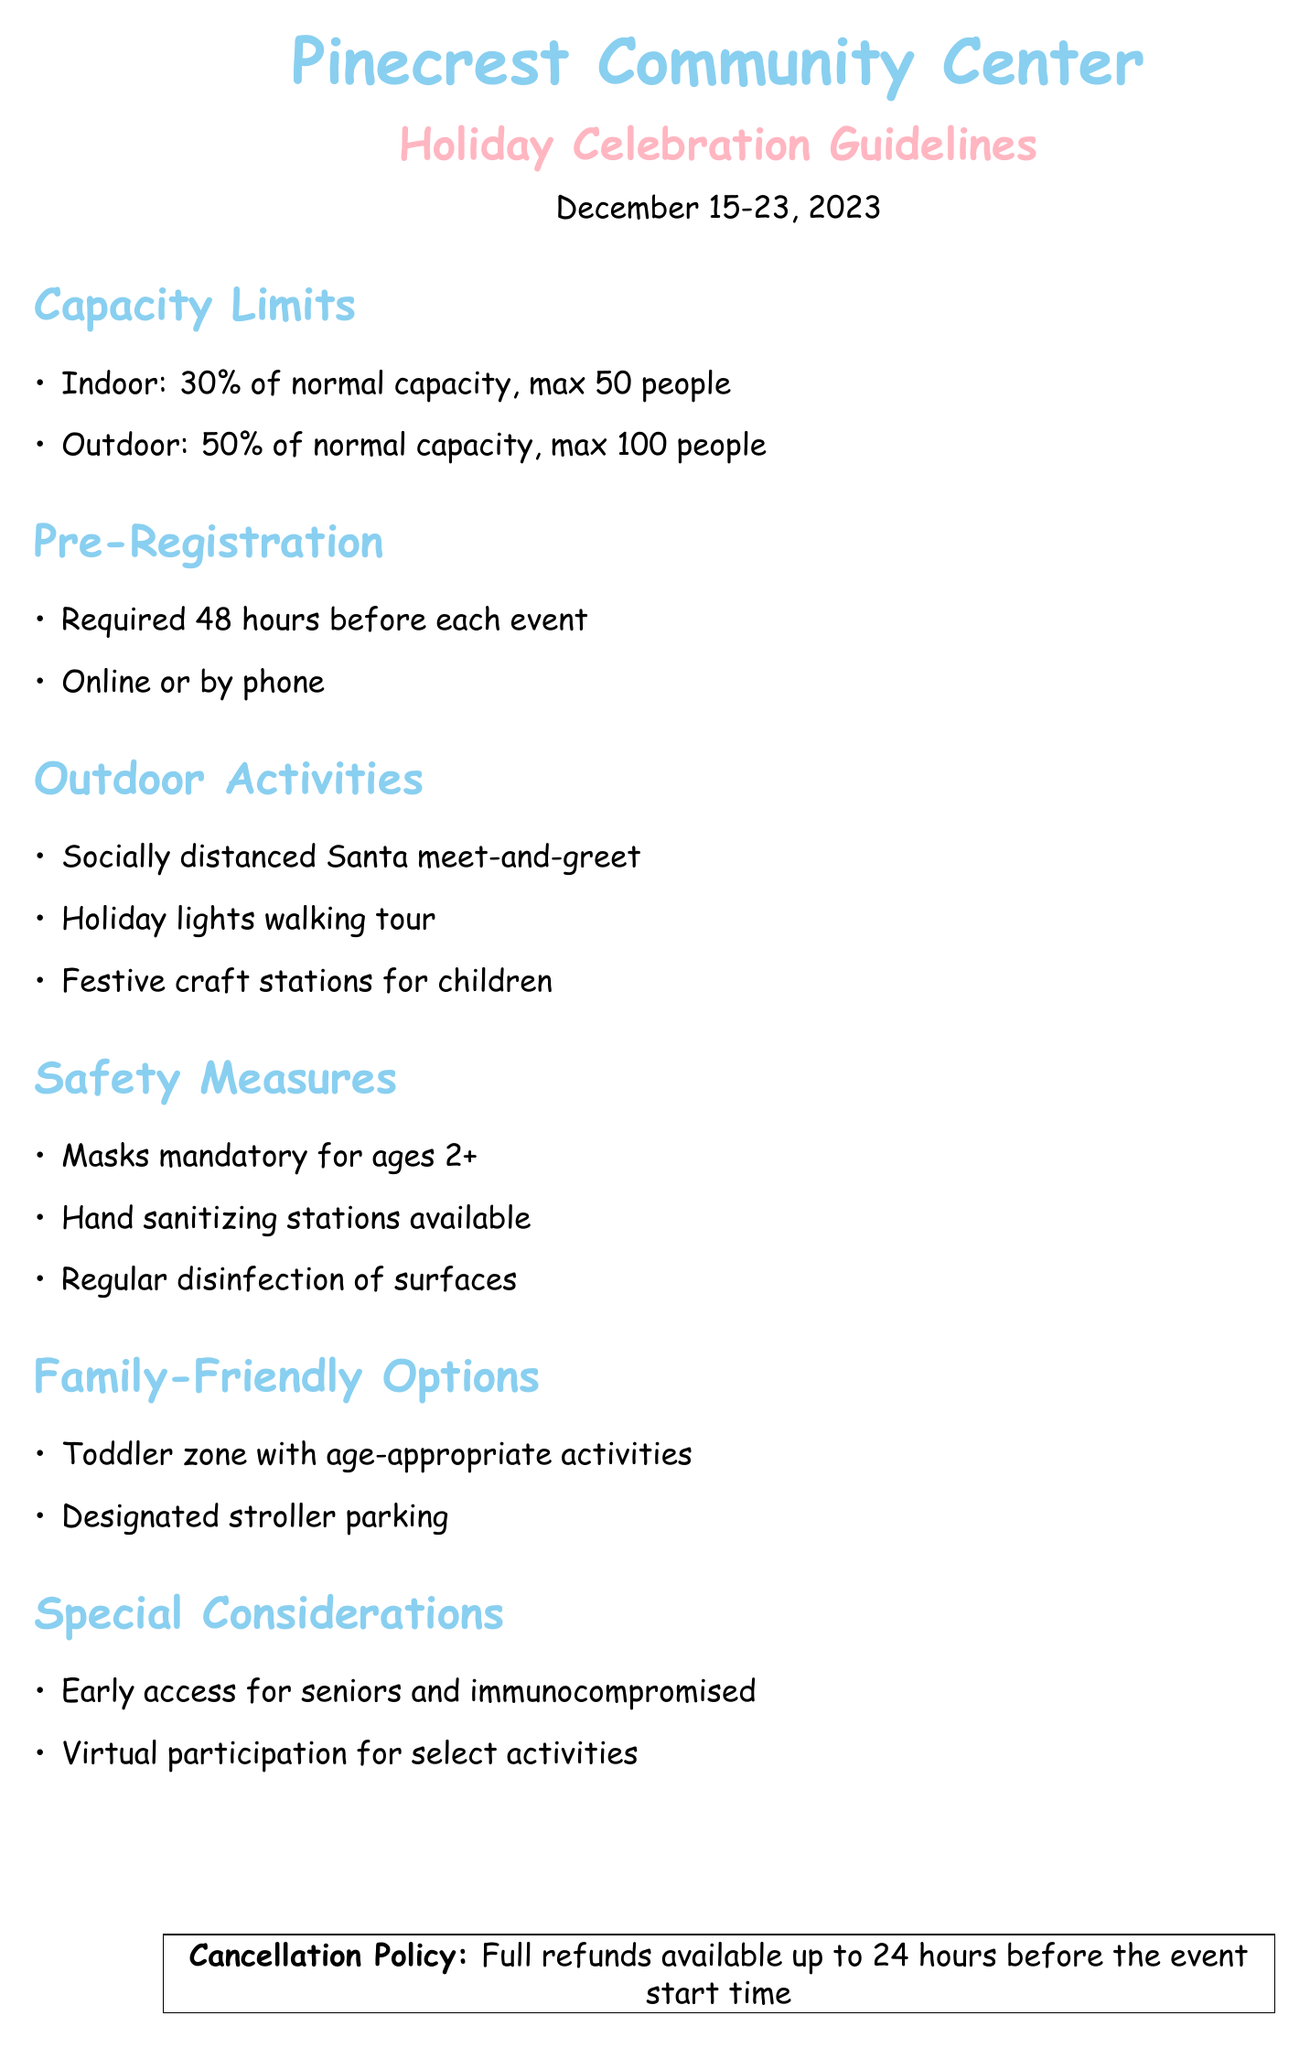What is the maximum indoor capacity for the holiday events? The maximum indoor capacity is specified in the guidelines as 50 people.
Answer: 50 people What are the pre-registration requirements? The guidelines state that pre-registration is required 48 hours before each event, either online or by phone.
Answer: 48 hours, online or by phone What is the maximum outdoor capacity for the holiday events? The guidelines specify that the maximum outdoor capacity is 100 people.
Answer: 100 people What types of activities are planned for outdoor events? The document outlines outdoor activities including a Santa meet-and-greet, walking tour, and craft stations.
Answer: Santa meet-and-greet, holiday lights walking tour, festive craft stations What measures are required for masks? The guidelines state that masks are mandatory for individuals aged 2 and older.
Answer: Mandatory for ages 2+ What provisions exist for families with toddlers? The guidelines mention a toddler zone with age-appropriate activities and designated stroller parking.
Answer: Toddler zone, designated stroller parking What special consideration is available for seniors? The document notes that there is early access for seniors and the immunocompromised.
Answer: Early access for seniors and immunocompromised What is the cancellation policy for events? The guidelines state that full refunds are available up to 24 hours before the event start time.
Answer: Full refunds available up to 24 hours before What activities allow for virtual participation? The guidelines specify that virtual participation is available for select activities, though not detailed specifically.
Answer: Select activities 